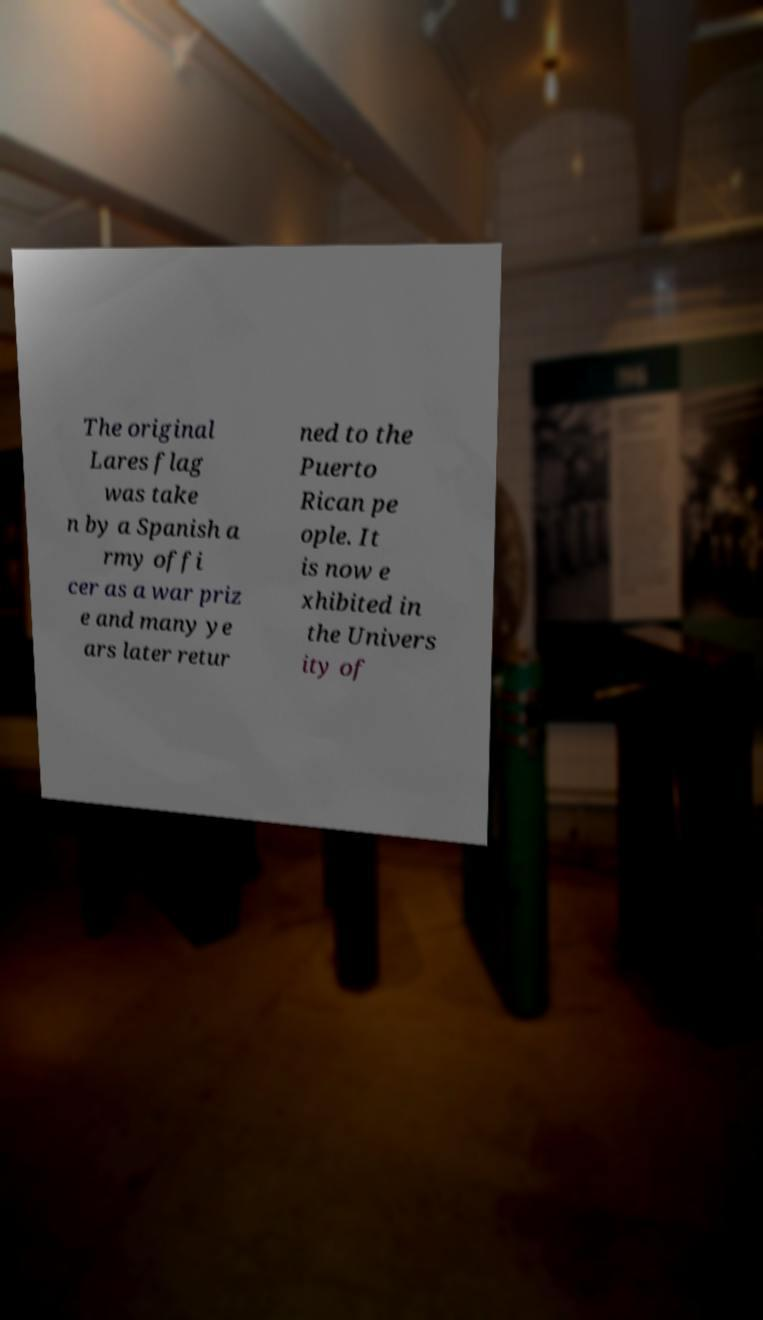For documentation purposes, I need the text within this image transcribed. Could you provide that? The original Lares flag was take n by a Spanish a rmy offi cer as a war priz e and many ye ars later retur ned to the Puerto Rican pe ople. It is now e xhibited in the Univers ity of 